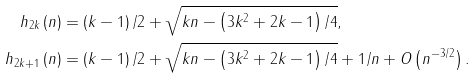<formula> <loc_0><loc_0><loc_500><loc_500>h _ { 2 k } \left ( n \right ) & = \left ( k - 1 \right ) / 2 + \sqrt { k n - \left ( 3 k ^ { 2 } + 2 k - 1 \right ) / 4 } , \\ h _ { 2 k + 1 } \left ( n \right ) & = \left ( k - 1 \right ) / 2 + \sqrt { k n - \left ( 3 k ^ { 2 } + 2 k - 1 \right ) / 4 } + 1 / n + O \left ( n ^ { - 3 / 2 } \right ) .</formula> 